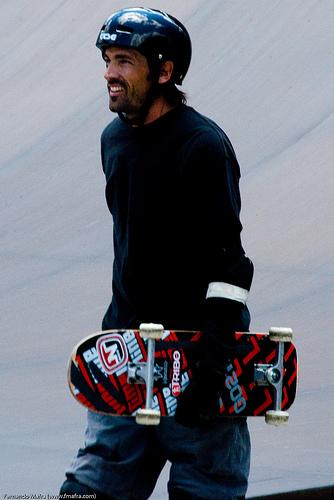Explain what the person is holding and their attire. The man is holding a large, colored skateboard wearing a black shirt with a white band, blue jeans, and a black helmet. Mention the important features of the skateboard and its wheels in the image. The skateboard is red, black, and white, has words on it, and features white wheels with silver brackets. Identify the accessories worn by the person in the image. The person is wearing a black helmet with a strap, a black shirt with a white stripe, blue jeans, and black gloves. Mention any words or text present in the image. There are words on the photo and words on the skateboard. Describe the facial features of the person in the image. The man has a beard, mustache, a nose, an ear, an eye, and is smiling, showing his white teeth. Provide a brief overview of the scene in the image. A smiling man wearing a helmet and holding a colored skateboard with white wheels is standing near a halfpipe. Describe the jeans worn by the man in the image. The man is wearing crumpled blue jeans. Explain the elements related to the personal safety of the person in the image. The man is wearing a black helmet on his head and there is a knee pad for protection. Highlight the visible details regarding the man's shirt. The man is wearing a black shirt with a white stripe on the arm and a white band on the back. Identify specific details about the man's headwear and facial hair in the image. The man is wearing a black helmet with light reflecting off it and has a beard and mustache on his face. 